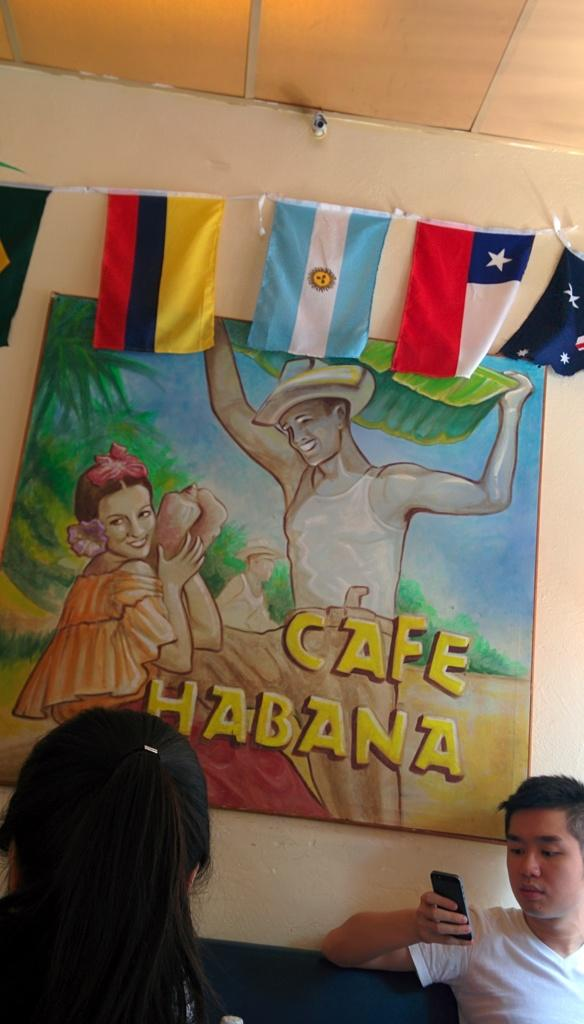How many people are in the image? There are two people in the image. What is the person on the left wearing? The person on the left is wearing a white shirt. What is the person in the white shirt holding? The person in the white shirt is holding a mobile in his hand. What can be seen in the background of the image? There is a group of plants and a photo frame on the wall in the background of the image. How does the honey increase in the image? There is no honey present in the image, so it cannot increase. 